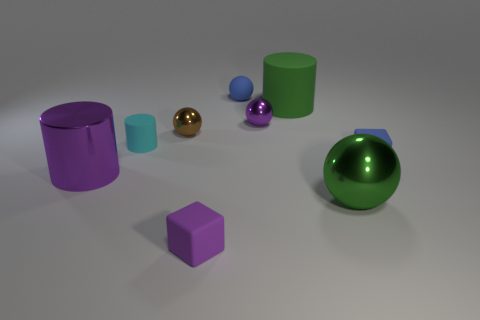Subtract all cylinders. How many objects are left? 6 Add 9 tiny brown spheres. How many tiny brown spheres are left? 10 Add 1 big metal balls. How many big metal balls exist? 2 Subtract 1 green cylinders. How many objects are left? 8 Subtract all small green rubber things. Subtract all tiny objects. How many objects are left? 3 